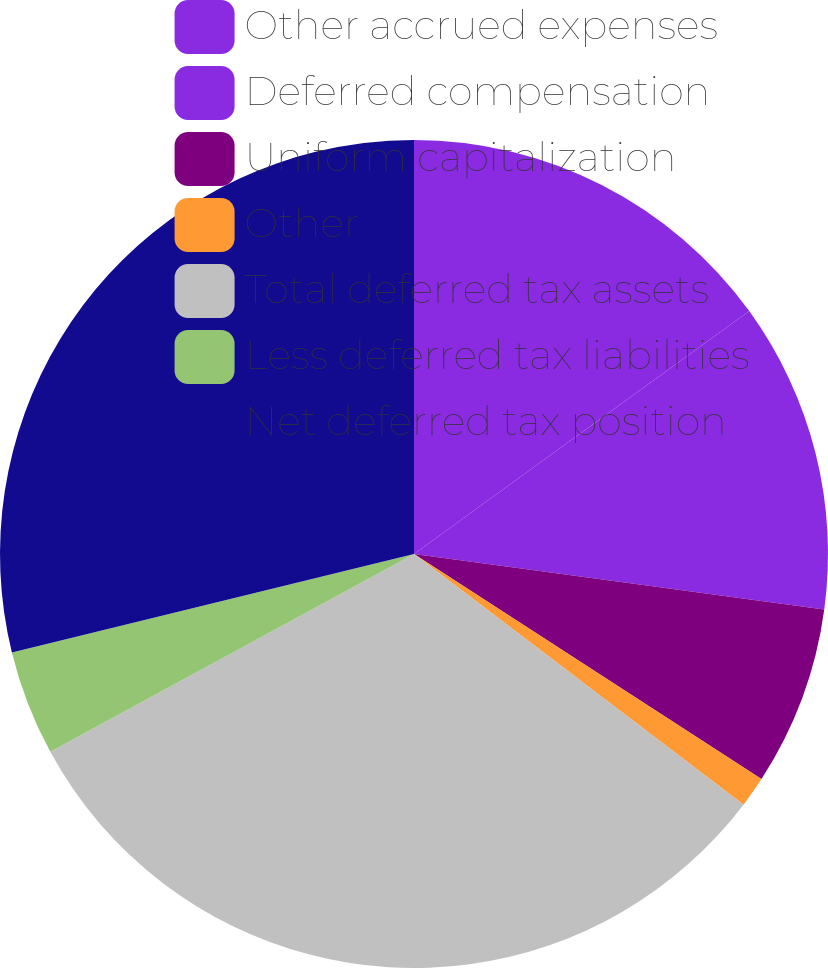Convert chart to OTSL. <chart><loc_0><loc_0><loc_500><loc_500><pie_chart><fcel>Other accrued expenses<fcel>Deferred compensation<fcel>Uniform capitalization<fcel>Other<fcel>Total deferred tax assets<fcel>Less deferred tax liabilities<fcel>Net deferred tax position<nl><fcel>15.02%<fcel>12.12%<fcel>7.01%<fcel>1.2%<fcel>31.72%<fcel>4.11%<fcel>28.82%<nl></chart> 